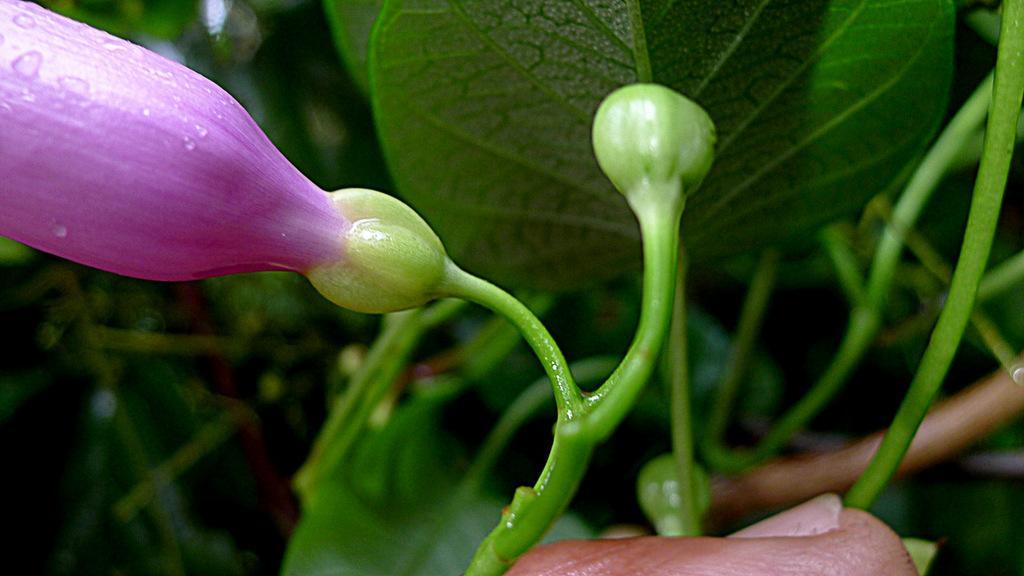Please provide a concise description of this image. In this image there is a plant to that plant there is a flower. 